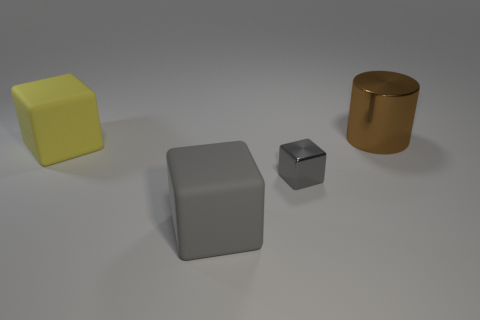Are there any big things that have the same shape as the tiny thing?
Keep it short and to the point. Yes. The big cube that is right of the large matte block that is behind the metallic thing that is to the left of the shiny cylinder is made of what material?
Offer a very short reply. Rubber. What number of other objects are the same size as the yellow rubber thing?
Your answer should be very brief. 2. What color is the tiny metallic object?
Make the answer very short. Gray. How many shiny things are gray objects or small gray objects?
Make the answer very short. 1. Is there any other thing that is the same material as the brown thing?
Keep it short and to the point. Yes. How big is the object that is behind the rubber object that is to the left of the large block that is to the right of the yellow matte cube?
Your response must be concise. Large. There is a object that is in front of the brown metallic cylinder and to the right of the big gray thing; how big is it?
Ensure brevity in your answer.  Small. There is a metallic thing to the left of the large cylinder; does it have the same color as the large rubber thing to the left of the big gray block?
Keep it short and to the point. No. What number of cubes are behind the large cylinder?
Provide a succinct answer. 0. 